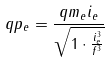Convert formula to latex. <formula><loc_0><loc_0><loc_500><loc_500>q p _ { e } = \frac { q m _ { e } i _ { e } } { \sqrt { 1 \cdot \frac { i _ { e } ^ { 3 } } { f ^ { 3 } } } }</formula> 